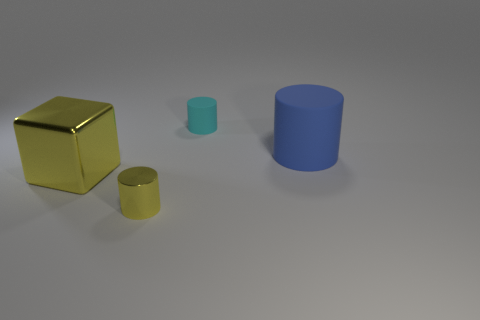How many things are big blue rubber objects or gray cubes? In the image, there is one large blue cylinder that qualifies as a big blue rubber object. There are no gray cubes present. So, there is a total of one item fitting the description provided. 